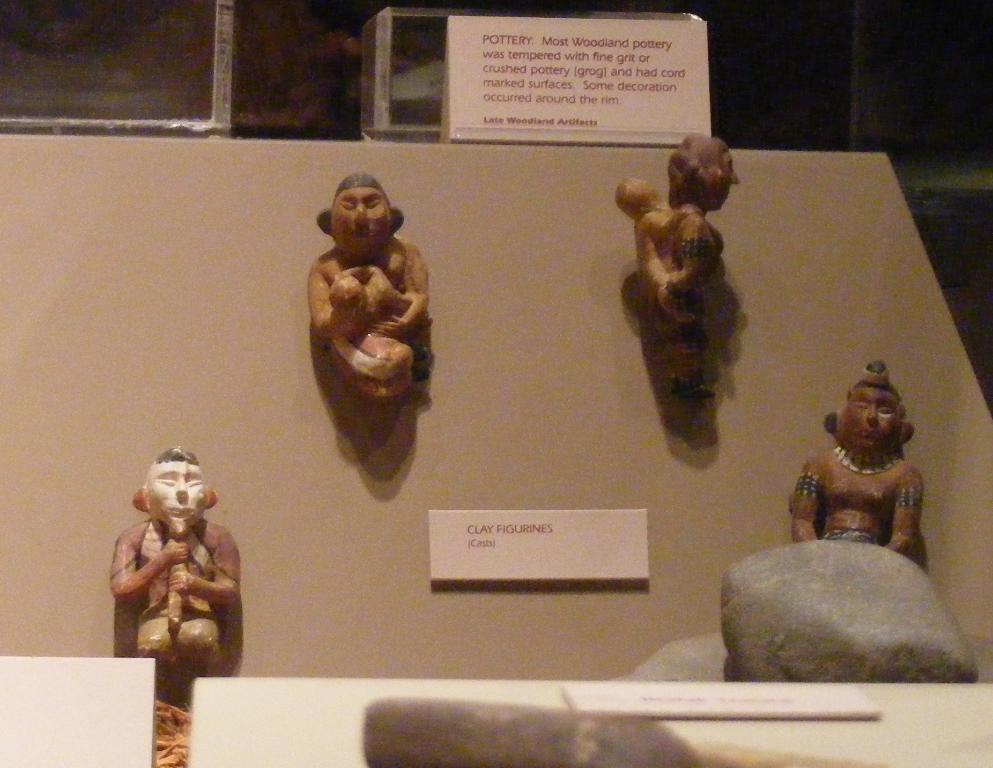What is the main subject of the image? The main subject of the image is a statue of persons. What is placed on top of the statue? There is a poster on top of the statue. What can be seen near the stones in the image? There is a nameplate near the stones in the image. What architectural feature is visible in the top background of the image? There are racks visible in the top background of the image. What type of pie is being served to the crowd in the image? There is no pie or crowd present in the image; it features a statue with a poster, a nameplate, and racks in the background. 